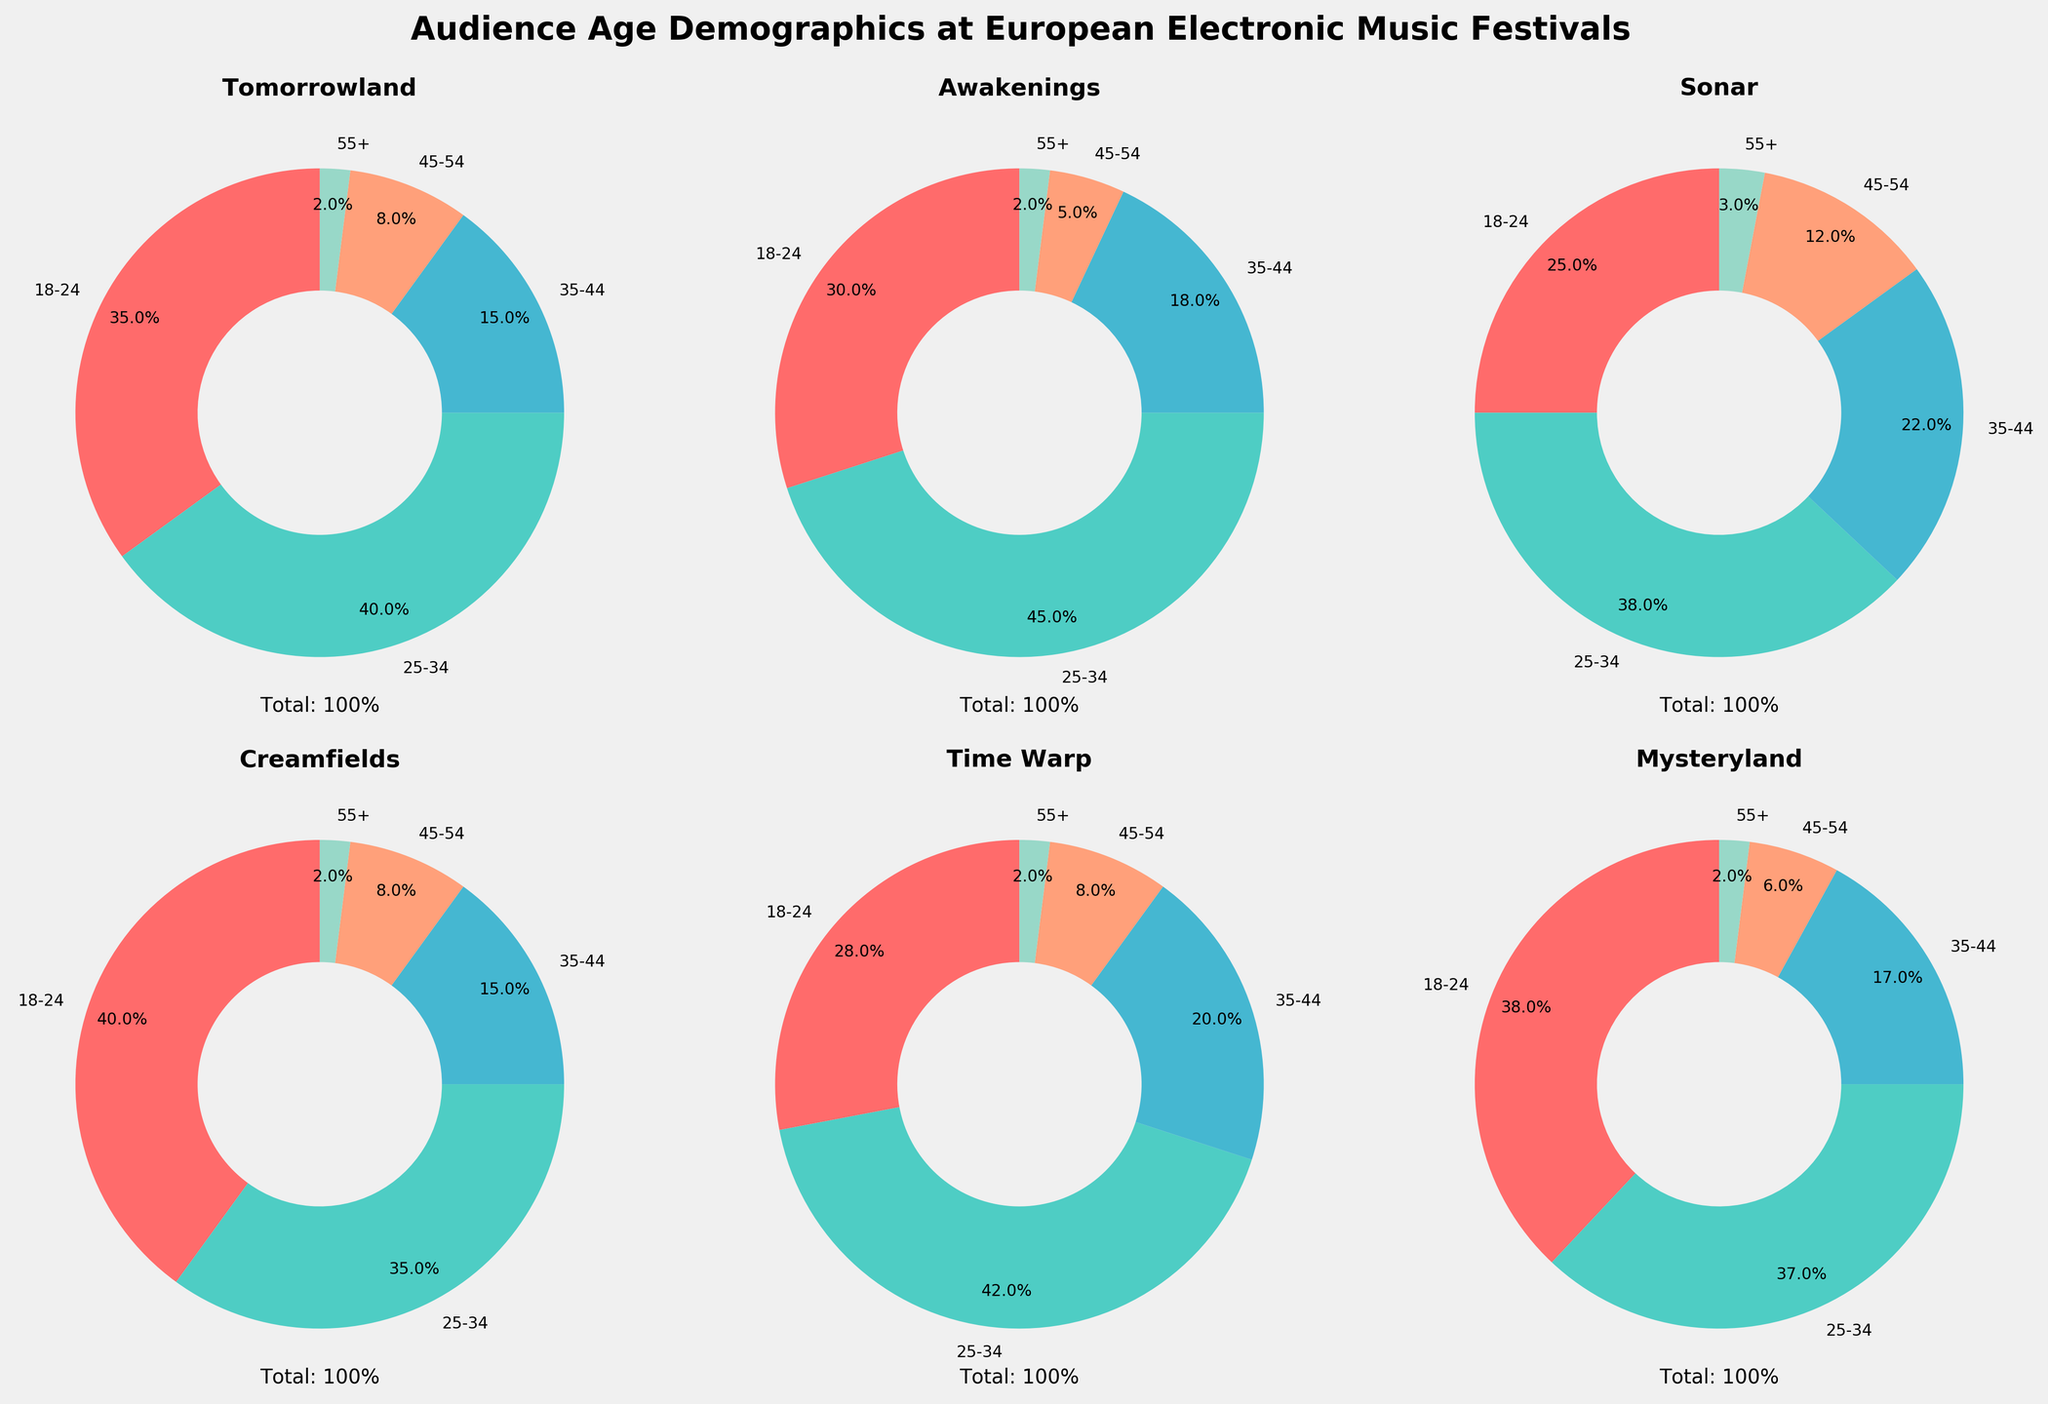What is the title of the figure? The title is found at the top of the figure and usually describes the main subject of the plot. In this case, reading the top of the figure will show the title.
Answer: Audience Age Demographics at European Electronic Music Festivals Which festival has the highest percentage of attendees aged 18-24? By examining each pie chart and the percentage labels for the 18-24 age group, you can determine which festival has the highest percentage in this category.
Answer: Creamfields How many festivals have a greater percentage of attendees aged 25-34 than aged 35-44? For each pie chart, compare the percentages of the 25-34 age group and the 35-44 age group to count the festivals where the 25-34 percentage is higher.
Answer: 5 Which festival has the closest age demographic distribution between the 18-24 and 25-34 age groups? Compare the percentages of the 18-24 and 25-34 age groups for each festival to find the one with the smallest difference between these two percentages.
Answer: Tomorrowland What is the average percentage of attendees aged 45-54 across all festivals? Sum the percentages of attendees aged 45-54 from each festival and divide by the number of festivals to calculate the average. (8 + 5 + 12 + 8 + 8 + 6) / 6 = 7.83
Answer: 7.83 Which festival has the most balanced age demographic distribution (i.e., the smallest difference between its largest and smallest age groups)? For each festival, calculate the difference between the largest and smallest percentages and compare these differences to determine the smallest one.
Answer: Sonar 